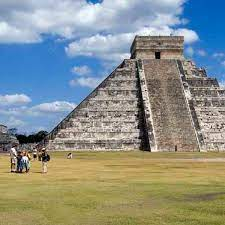If you were an ancient Mayan visiting Chichen Itza for the first time, what would impress you the most? As an ancient Mayan visiting Chichen Itza for the first time, several elements would likely leave a profound impression. The sheer scale and grandeur of the Pyramid of Kukulkan would be awe-inspiring, its towering presence a testament to communal effort and divine inspiration. The precision of the stone carvings and reliefs depicting gods, rituals, and mythological creatures would captivate attention, reflecting the intricate artistry and religious devotion of the builders. The acoustics of the Great Ball Court, designed to mimic the call of the Quetzal bird, would be another marvel, showcasing the ingenuity and understanding of sound and space. Finally, the alignment of key structures with celestial events would reinforce the significance of astronomy in guiding the civilization’s spiritual and agricultural practices. 